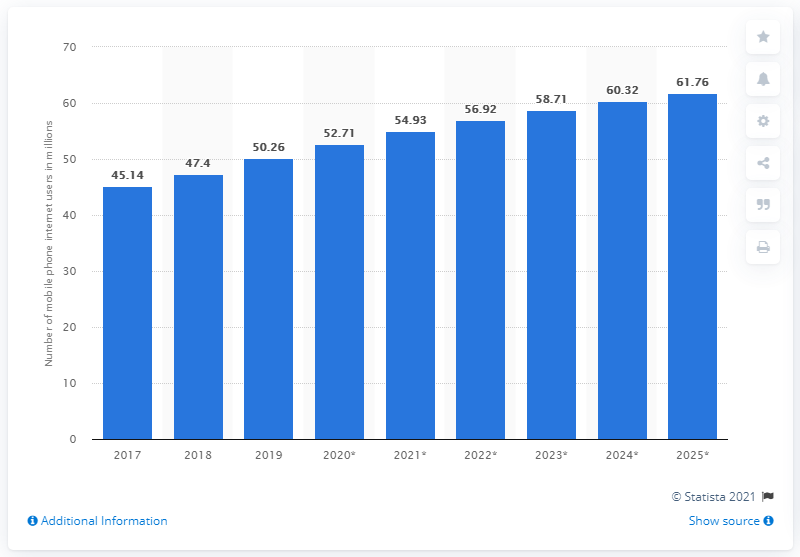Mention a couple of crucial points in this snapshot. According to projections, the number of mobile internet users in Thailand is expected to reach 61.76 million in 2025. In 2019, it is estimated that 50.26% of the population in Thailand accessed the internet through their mobile phones. 